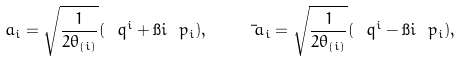Convert formula to latex. <formula><loc_0><loc_0><loc_500><loc_500>\ a _ { i } = \sqrt { \frac { 1 } { 2 \theta _ { ( i ) } } } ( \ q ^ { i } + \i i \ p _ { i } ) , \quad \bar { \ a } _ { i } = \sqrt { \frac { 1 } { 2 \theta _ { ( i ) } } } ( \ q ^ { i } - \i i \ p _ { i } ) ,</formula> 